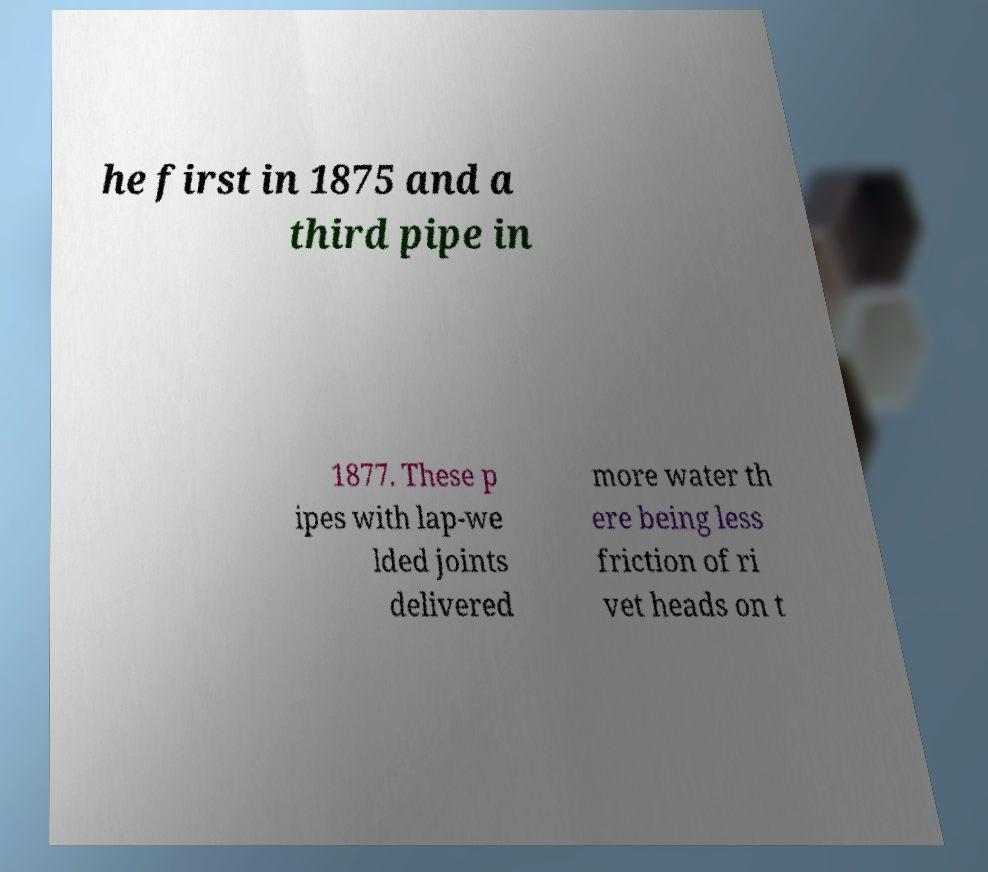There's text embedded in this image that I need extracted. Can you transcribe it verbatim? he first in 1875 and a third pipe in 1877. These p ipes with lap-we lded joints delivered more water th ere being less friction of ri vet heads on t 